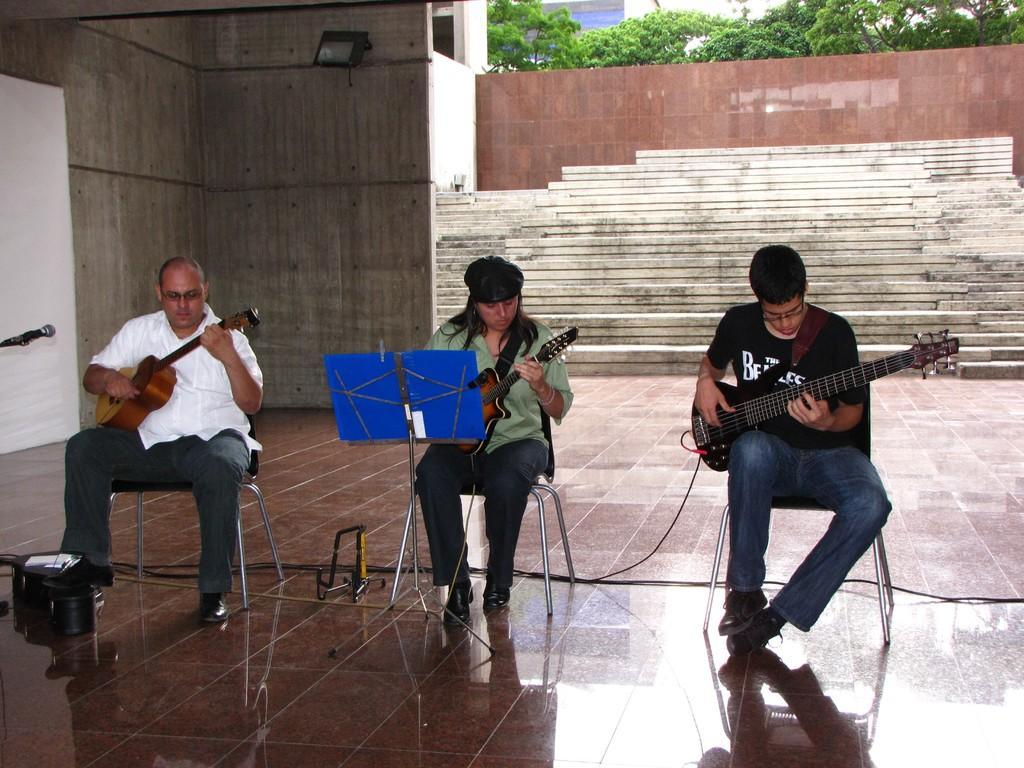Describe this image in one or two sentences. It looks like a music class there are three people sitting on a table and playing the guitar they are sitting on a marble floor, in the background there is a wooden wall above it there are few trees. 